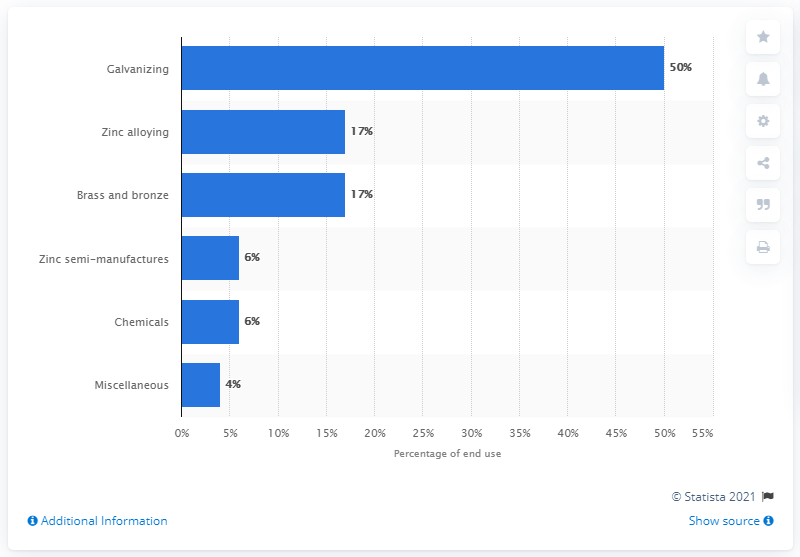Point out several critical features in this image. It is estimated that alloying accounts for approximately 17% of global zinc consumption. 